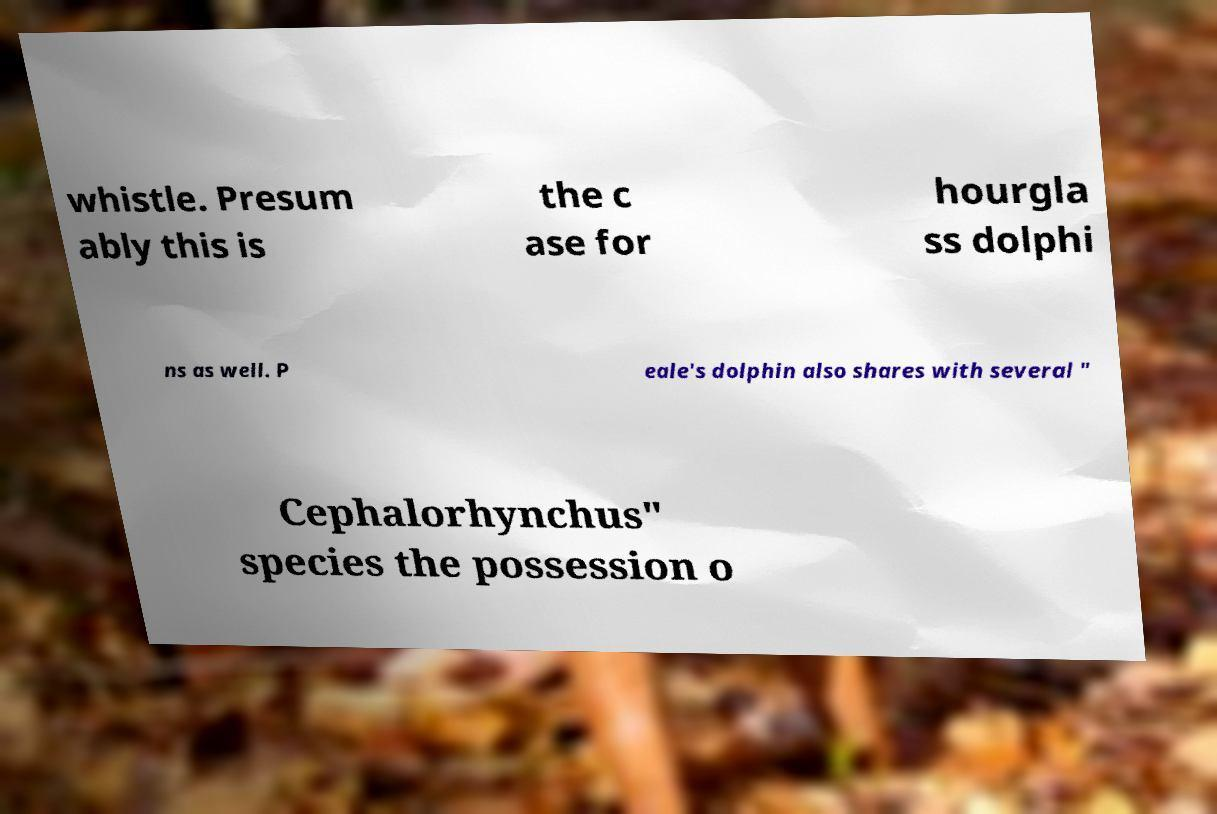Please identify and transcribe the text found in this image. whistle. Presum ably this is the c ase for hourgla ss dolphi ns as well. P eale's dolphin also shares with several " Cephalorhynchus" species the possession o 